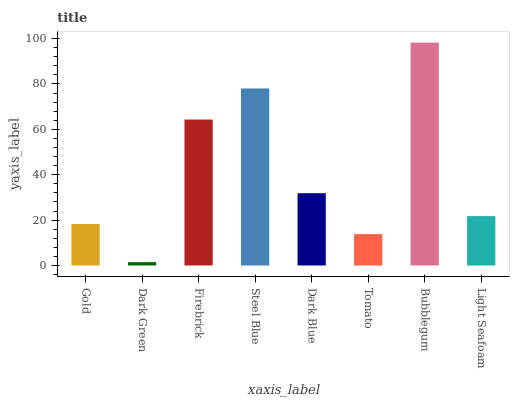Is Dark Green the minimum?
Answer yes or no. Yes. Is Bubblegum the maximum?
Answer yes or no. Yes. Is Firebrick the minimum?
Answer yes or no. No. Is Firebrick the maximum?
Answer yes or no. No. Is Firebrick greater than Dark Green?
Answer yes or no. Yes. Is Dark Green less than Firebrick?
Answer yes or no. Yes. Is Dark Green greater than Firebrick?
Answer yes or no. No. Is Firebrick less than Dark Green?
Answer yes or no. No. Is Dark Blue the high median?
Answer yes or no. Yes. Is Light Seafoam the low median?
Answer yes or no. Yes. Is Dark Green the high median?
Answer yes or no. No. Is Dark Blue the low median?
Answer yes or no. No. 